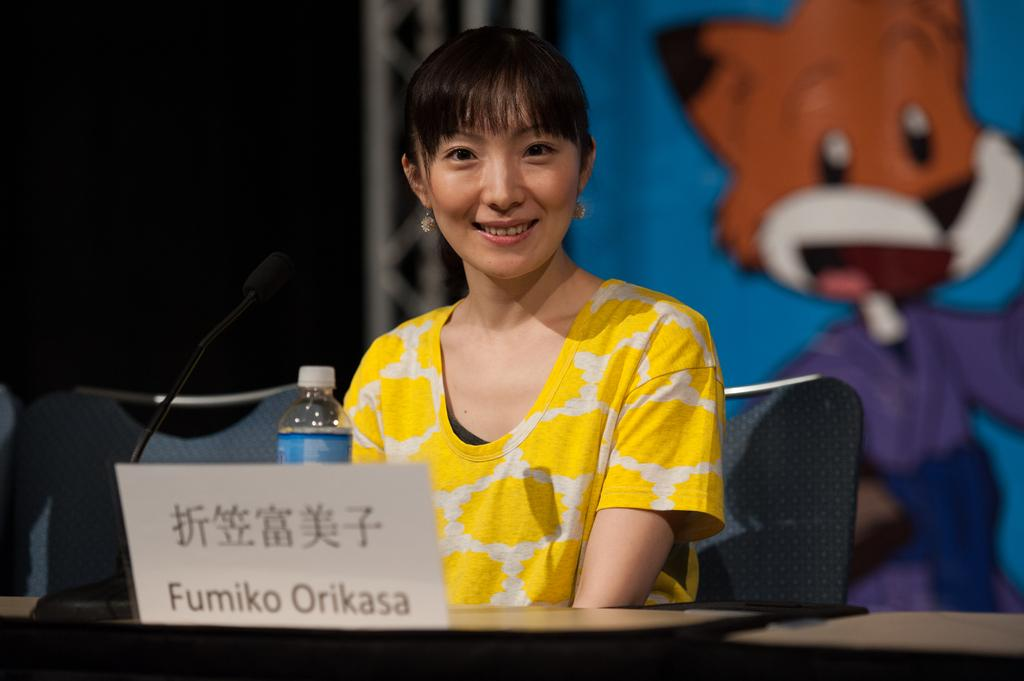Who is present in the image? There is a woman in the image. What is the woman doing in the image? The woman is sitting on a chair and smiling. What objects can be seen on the table in the image? There is a bottle and a microphone (mike) on the table. What is visible in the background of the image? There is a cartoon in the background of the image. How does the woman increase the volume of the vegetable in the image? There is no vegetable present in the image, and the woman is not adjusting any volume. 